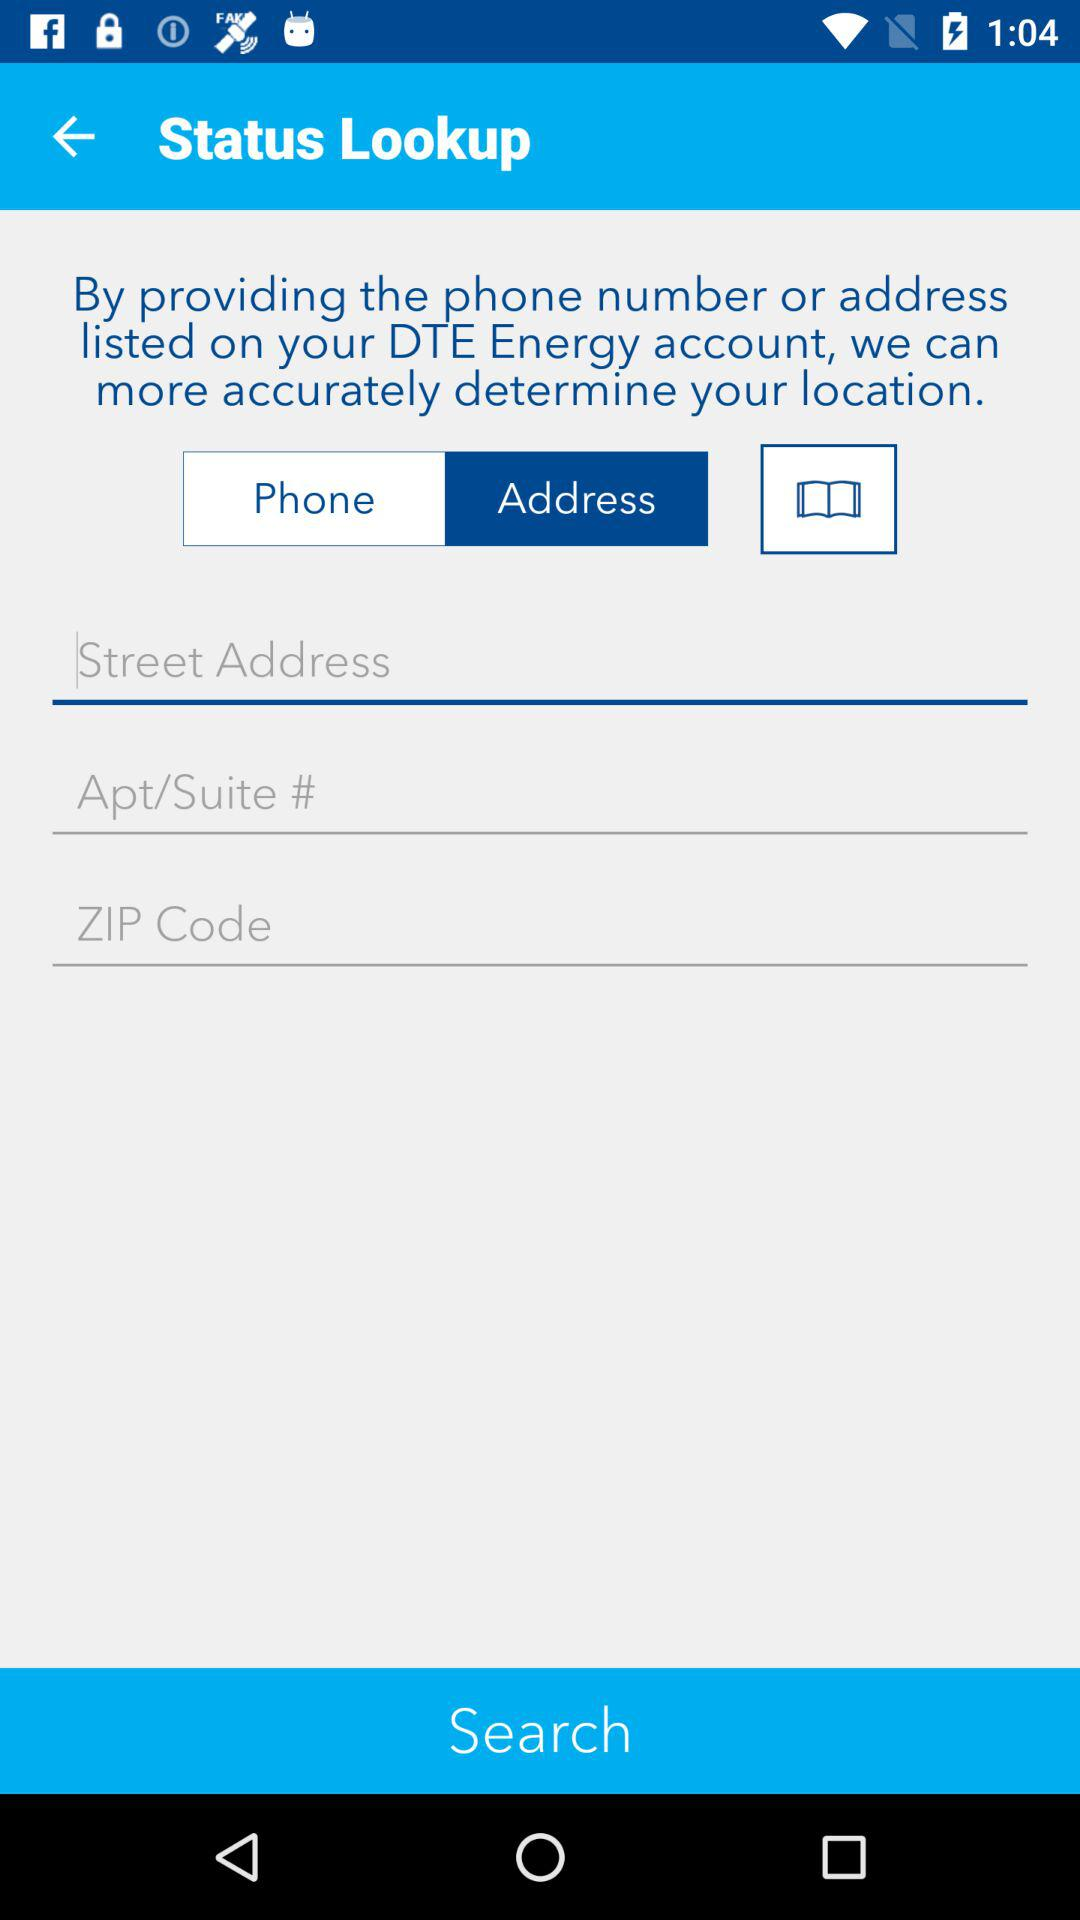Which tab is selected? The selected tab is "Address". 